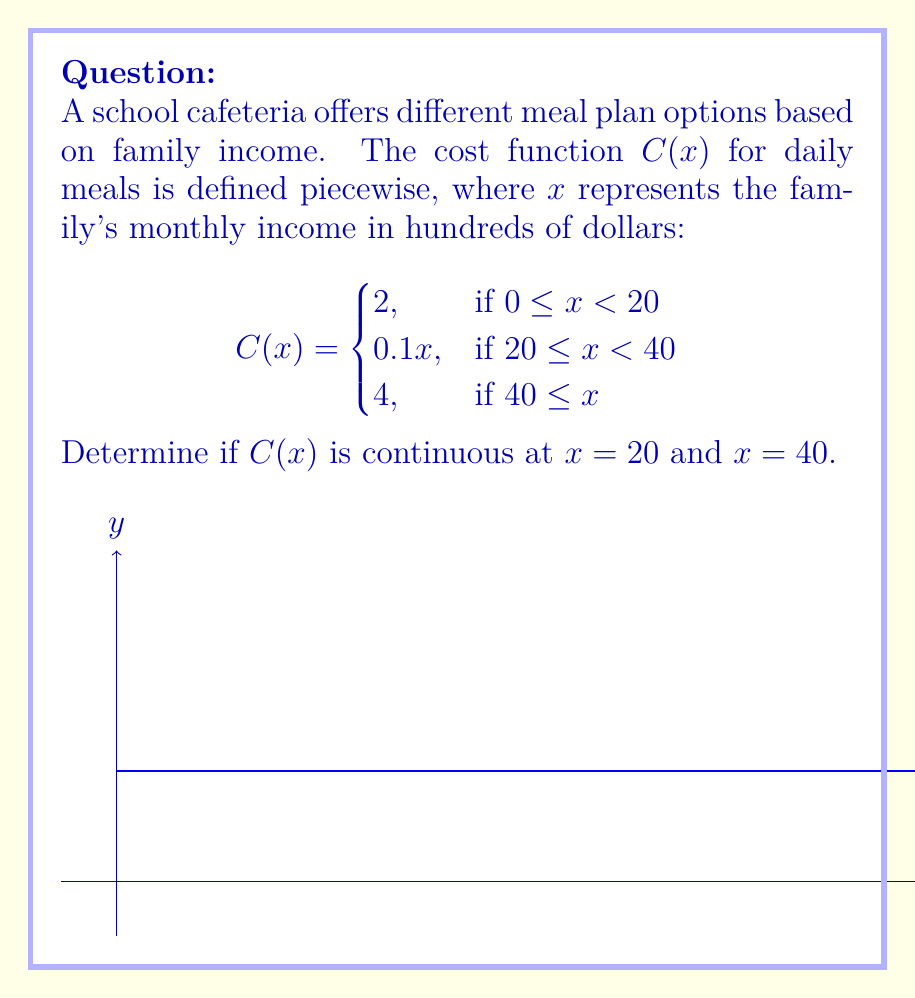Give your solution to this math problem. To determine continuity at $x = 20$ and $x = 40$, we need to check three conditions for each point:
1. The function is defined at the point.
2. The limit of the function as we approach the point from both sides exists.
3. The limit equals the function value at that point.

For $x = 20$:
1. $C(20)$ is defined: $C(20) = 0.1(20) = 2$
2. Left limit: $\lim_{x \to 20^-} C(x) = 2$
   Right limit: $\lim_{x \to 20^+} C(x) = 0.1(20) = 2$
3. $\lim_{x \to 20} C(x) = C(20) = 2$

All conditions are met, so $C(x)$ is continuous at $x = 20$.

For $x = 40$:
1. $C(40)$ is defined: $C(40) = 4$
2. Left limit: $\lim_{x \to 40^-} C(x) = 0.1(40) = 4$
   Right limit: $\lim_{x \to 40^+} C(x) = 4$
3. $\lim_{x \to 40} C(x) = C(40) = 4$

All conditions are met, so $C(x)$ is continuous at $x = 40$.
Answer: $C(x)$ is continuous at both $x = 20$ and $x = 40$. 